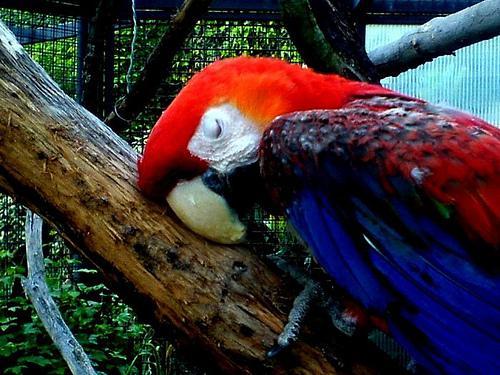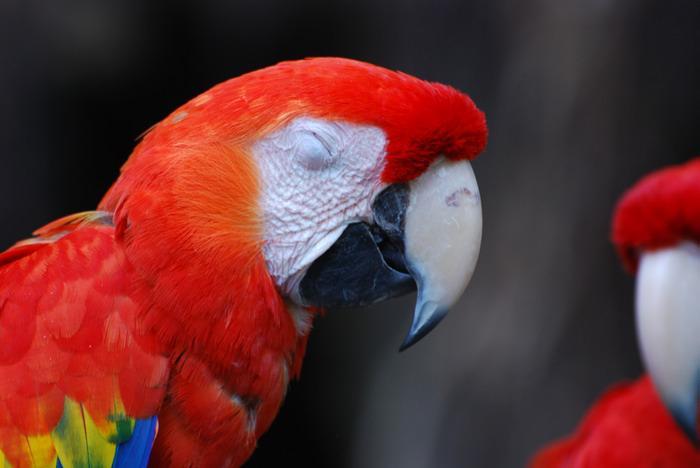The first image is the image on the left, the second image is the image on the right. Evaluate the accuracy of this statement regarding the images: "A single red and blue parrot feet are holding on to a piece of wood.". Is it true? Answer yes or no. Yes. The first image is the image on the left, the second image is the image on the right. Considering the images on both sides, is "The left image contains two parrots perched on a branch." valid? Answer yes or no. No. 